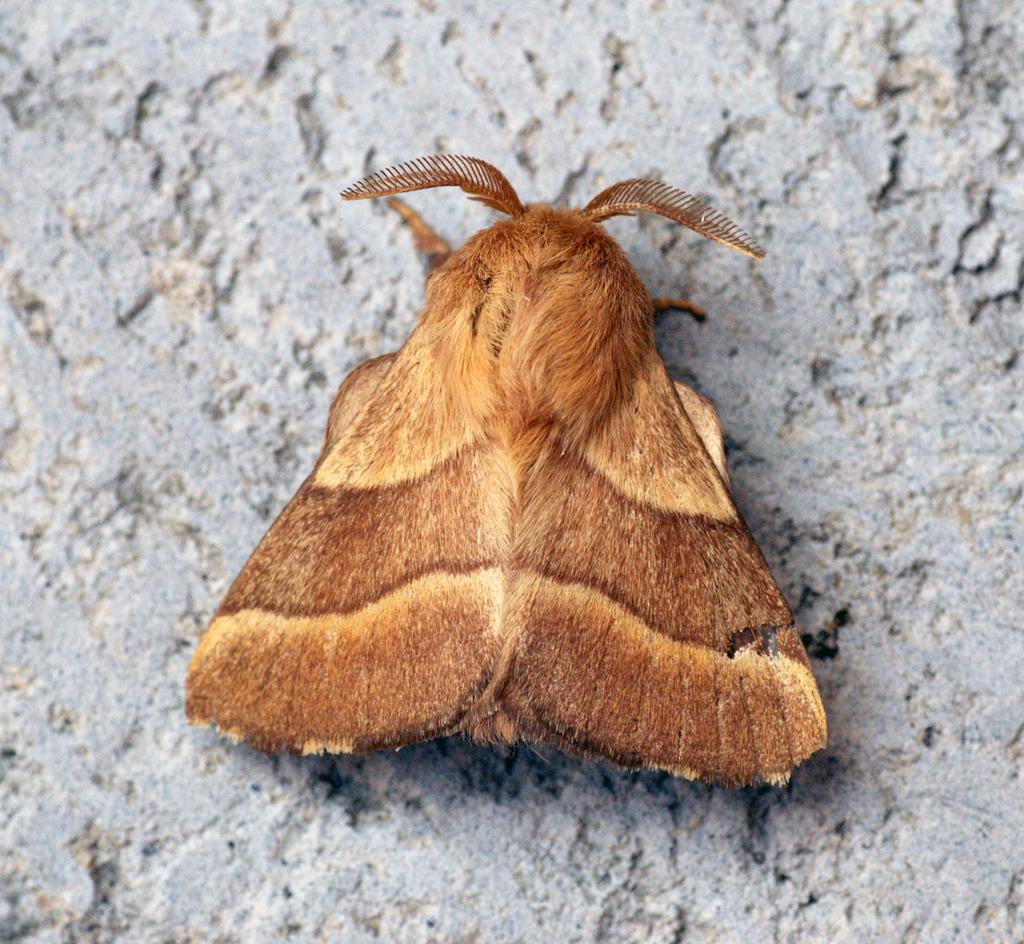What type of creature can be seen in the image? There is an insect in the image. Where is the insect located? The insect is on the wall. What type of tree is the crow perched on in the image? There is no tree or crow present in the image; it only features an insect on the wall. What dish is being served for dinner in the image? There is no dinner or dish present in the image; it only features an insect on the wall. 